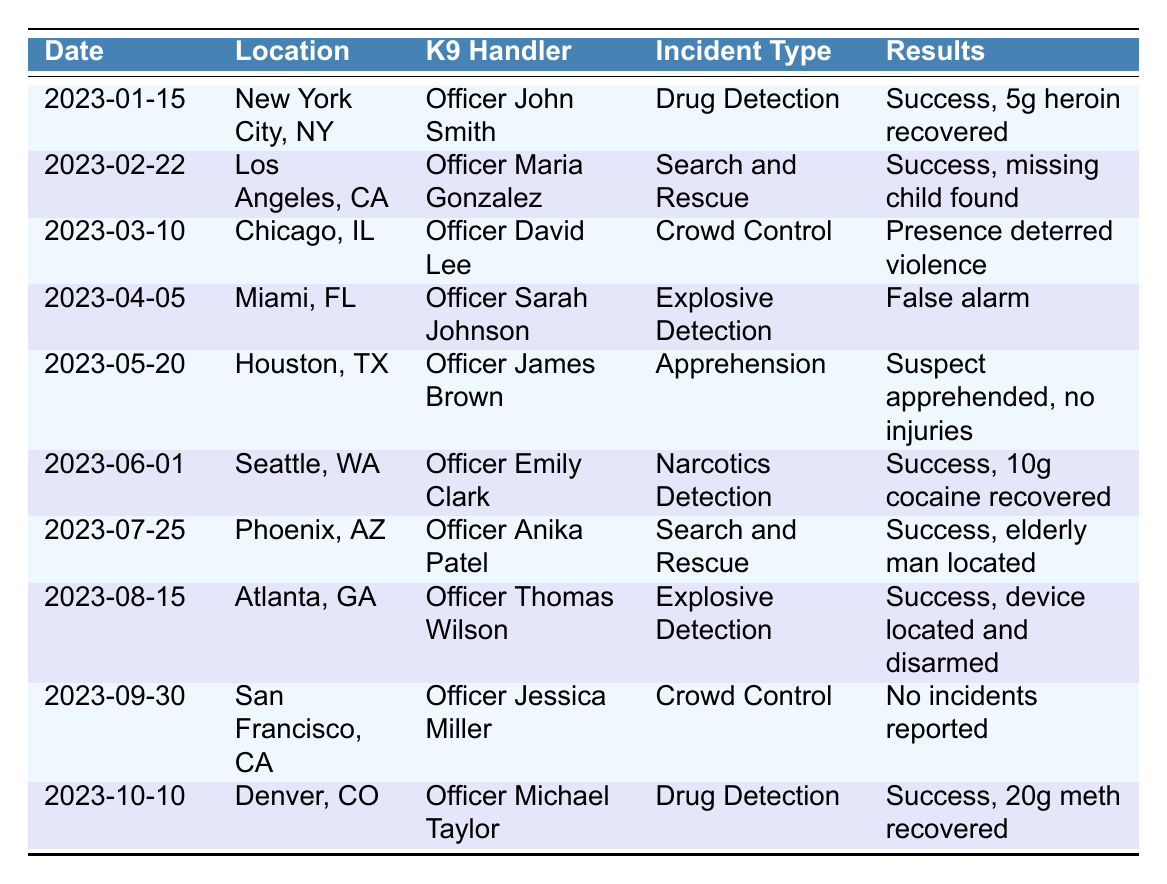What is the location of the incident with ID IR005? From the table, we can find the row with incident ID IR005. The corresponding location in that row is "Houston, TX."
Answer: Houston, TX Who was the handler for the K9 unit named Bella? By looking at the row that contains "Bella" under the K9 unit column, we see that the handler is "Officer Maria Gonzalez."
Answer: Officer Maria Gonzalez How many incidents involved drug detection? Searching through the table, we find two entries for "Drug Detection" (IR001 and IR010). Therefore, the total number of incidents is 2.
Answer: 2 What type of incident was reported in Chicago, IL? By locating the row with "Chicago, IL" in the location column, we can see that the incident type listed is "Crowd Control."
Answer: Crowd Control Was there an incident in Miami, FL involving a successful results outcome? Looking at the row for Miami, FL, the result indicates a "False alarm," therefore the answer is no.
Answer: No Which incident had the most significant substance recovered? By finding all the incidents related to drug detection (IR001 and IR010), we see that IR010 had 20 grams of methamphetamine recovered, which is more than the 5 grams of heroin in IR001.
Answer: IR010 What was the date of the incident where an elderly man was located? The table shows a successful search and rescue incident for "elderly man located" on "2023-07-25."
Answer: 2023-07-25 Which K9 unit was involved in the explosive detection incident in Atlanta, GA? The row for Atlanta, GA shows that the K9 unit involved in the explosive detection incident was "Toby."
Answer: Toby How many different types of incidents are listed in the table? The incidents in the table include "Drug Detection," "Search and Rescue," "Crowd Control," "Explosive Detection," and "Apprehension," totaling five different types.
Answer: 5 Which reporting agency had a report with no incidents? The row in the table for the incident in San Francisco, CA, reports "No incidents reported," and the corresponding agency is "SFPD."
Answer: SFPD 